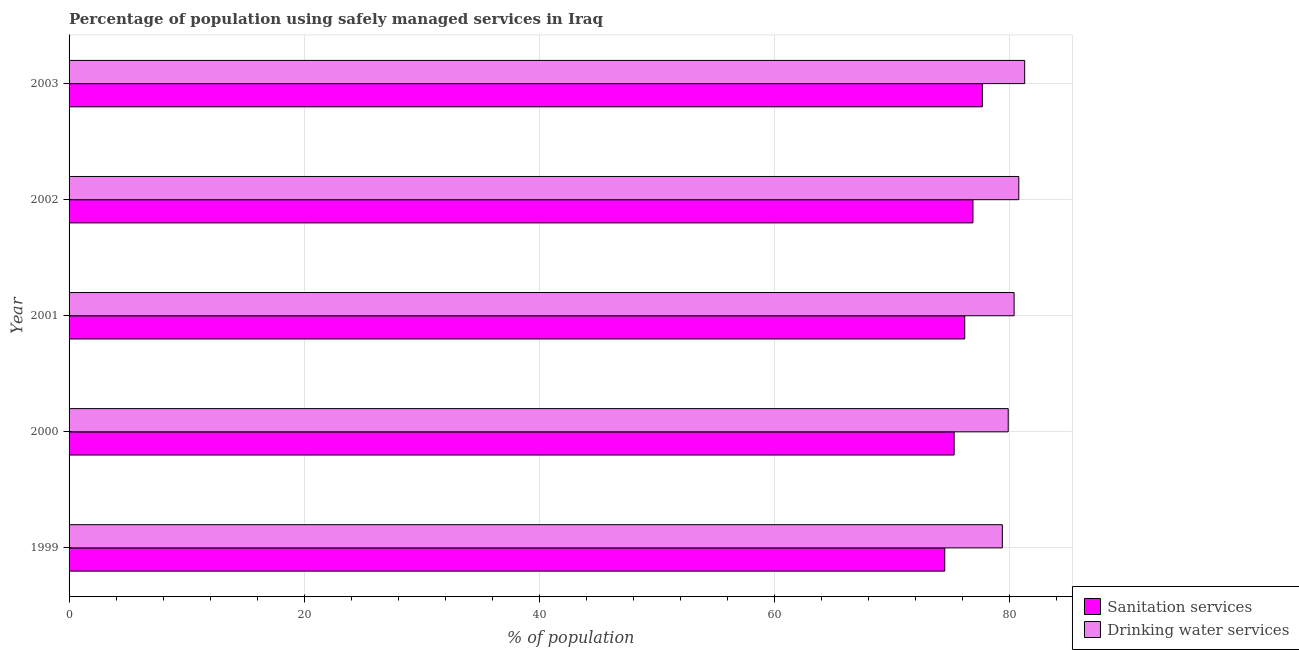How many different coloured bars are there?
Ensure brevity in your answer.  2. How many groups of bars are there?
Make the answer very short. 5. What is the label of the 4th group of bars from the top?
Provide a succinct answer. 2000. In how many cases, is the number of bars for a given year not equal to the number of legend labels?
Offer a terse response. 0. What is the percentage of population who used drinking water services in 2001?
Offer a very short reply. 80.4. Across all years, what is the maximum percentage of population who used sanitation services?
Ensure brevity in your answer.  77.7. Across all years, what is the minimum percentage of population who used drinking water services?
Offer a very short reply. 79.4. In which year was the percentage of population who used drinking water services maximum?
Offer a terse response. 2003. What is the total percentage of population who used drinking water services in the graph?
Offer a very short reply. 401.8. What is the difference between the percentage of population who used sanitation services in 2000 and that in 2001?
Ensure brevity in your answer.  -0.9. What is the difference between the percentage of population who used drinking water services in 2002 and the percentage of population who used sanitation services in 2003?
Your response must be concise. 3.1. What is the average percentage of population who used drinking water services per year?
Ensure brevity in your answer.  80.36. In the year 2002, what is the difference between the percentage of population who used drinking water services and percentage of population who used sanitation services?
Offer a very short reply. 3.9. What is the ratio of the percentage of population who used sanitation services in 1999 to that in 2001?
Your response must be concise. 0.98. Is the difference between the percentage of population who used sanitation services in 1999 and 2001 greater than the difference between the percentage of population who used drinking water services in 1999 and 2001?
Offer a very short reply. No. In how many years, is the percentage of population who used drinking water services greater than the average percentage of population who used drinking water services taken over all years?
Your answer should be very brief. 3. Is the sum of the percentage of population who used drinking water services in 2001 and 2002 greater than the maximum percentage of population who used sanitation services across all years?
Offer a terse response. Yes. What does the 2nd bar from the top in 2002 represents?
Give a very brief answer. Sanitation services. What does the 2nd bar from the bottom in 2001 represents?
Your answer should be compact. Drinking water services. Are all the bars in the graph horizontal?
Keep it short and to the point. Yes. How many years are there in the graph?
Make the answer very short. 5. Are the values on the major ticks of X-axis written in scientific E-notation?
Offer a terse response. No. Does the graph contain any zero values?
Your response must be concise. No. Does the graph contain grids?
Provide a short and direct response. Yes. Where does the legend appear in the graph?
Your answer should be very brief. Bottom right. How many legend labels are there?
Keep it short and to the point. 2. How are the legend labels stacked?
Your answer should be compact. Vertical. What is the title of the graph?
Offer a terse response. Percentage of population using safely managed services in Iraq. Does "Age 15+" appear as one of the legend labels in the graph?
Offer a very short reply. No. What is the label or title of the X-axis?
Your answer should be very brief. % of population. What is the % of population in Sanitation services in 1999?
Keep it short and to the point. 74.5. What is the % of population of Drinking water services in 1999?
Offer a terse response. 79.4. What is the % of population of Sanitation services in 2000?
Offer a very short reply. 75.3. What is the % of population of Drinking water services in 2000?
Your answer should be compact. 79.9. What is the % of population in Sanitation services in 2001?
Give a very brief answer. 76.2. What is the % of population in Drinking water services in 2001?
Provide a succinct answer. 80.4. What is the % of population of Sanitation services in 2002?
Provide a short and direct response. 76.9. What is the % of population in Drinking water services in 2002?
Your response must be concise. 80.8. What is the % of population of Sanitation services in 2003?
Provide a short and direct response. 77.7. What is the % of population of Drinking water services in 2003?
Your answer should be compact. 81.3. Across all years, what is the maximum % of population of Sanitation services?
Offer a terse response. 77.7. Across all years, what is the maximum % of population of Drinking water services?
Provide a succinct answer. 81.3. Across all years, what is the minimum % of population in Sanitation services?
Make the answer very short. 74.5. Across all years, what is the minimum % of population of Drinking water services?
Keep it short and to the point. 79.4. What is the total % of population of Sanitation services in the graph?
Give a very brief answer. 380.6. What is the total % of population of Drinking water services in the graph?
Keep it short and to the point. 401.8. What is the difference between the % of population in Drinking water services in 1999 and that in 2003?
Keep it short and to the point. -1.9. What is the difference between the % of population of Sanitation services in 2000 and that in 2001?
Offer a very short reply. -0.9. What is the difference between the % of population of Sanitation services in 2000 and that in 2002?
Ensure brevity in your answer.  -1.6. What is the difference between the % of population of Drinking water services in 2000 and that in 2002?
Offer a terse response. -0.9. What is the difference between the % of population in Drinking water services in 2000 and that in 2003?
Provide a succinct answer. -1.4. What is the difference between the % of population of Sanitation services in 2001 and that in 2002?
Provide a short and direct response. -0.7. What is the difference between the % of population of Drinking water services in 2001 and that in 2002?
Your answer should be compact. -0.4. What is the difference between the % of population of Sanitation services in 2001 and that in 2003?
Provide a short and direct response. -1.5. What is the difference between the % of population of Drinking water services in 2002 and that in 2003?
Offer a terse response. -0.5. What is the difference between the % of population in Sanitation services in 1999 and the % of population in Drinking water services in 2000?
Provide a succinct answer. -5.4. What is the difference between the % of population in Sanitation services in 1999 and the % of population in Drinking water services in 2003?
Offer a terse response. -6.8. What is the difference between the % of population of Sanitation services in 2000 and the % of population of Drinking water services in 2001?
Ensure brevity in your answer.  -5.1. What is the difference between the % of population in Sanitation services in 2001 and the % of population in Drinking water services in 2003?
Keep it short and to the point. -5.1. What is the average % of population in Sanitation services per year?
Ensure brevity in your answer.  76.12. What is the average % of population in Drinking water services per year?
Provide a succinct answer. 80.36. In the year 2000, what is the difference between the % of population in Sanitation services and % of population in Drinking water services?
Keep it short and to the point. -4.6. In the year 2001, what is the difference between the % of population in Sanitation services and % of population in Drinking water services?
Ensure brevity in your answer.  -4.2. What is the ratio of the % of population of Drinking water services in 1999 to that in 2000?
Your answer should be very brief. 0.99. What is the ratio of the % of population in Sanitation services in 1999 to that in 2001?
Your answer should be compact. 0.98. What is the ratio of the % of population in Drinking water services in 1999 to that in 2001?
Provide a succinct answer. 0.99. What is the ratio of the % of population of Sanitation services in 1999 to that in 2002?
Provide a short and direct response. 0.97. What is the ratio of the % of population in Drinking water services in 1999 to that in 2002?
Make the answer very short. 0.98. What is the ratio of the % of population of Sanitation services in 1999 to that in 2003?
Provide a succinct answer. 0.96. What is the ratio of the % of population of Drinking water services in 1999 to that in 2003?
Your response must be concise. 0.98. What is the ratio of the % of population in Sanitation services in 2000 to that in 2002?
Ensure brevity in your answer.  0.98. What is the ratio of the % of population in Drinking water services in 2000 to that in 2002?
Ensure brevity in your answer.  0.99. What is the ratio of the % of population of Sanitation services in 2000 to that in 2003?
Your answer should be compact. 0.97. What is the ratio of the % of population in Drinking water services in 2000 to that in 2003?
Provide a short and direct response. 0.98. What is the ratio of the % of population in Sanitation services in 2001 to that in 2002?
Your answer should be very brief. 0.99. What is the ratio of the % of population of Drinking water services in 2001 to that in 2002?
Provide a succinct answer. 0.99. What is the ratio of the % of population of Sanitation services in 2001 to that in 2003?
Give a very brief answer. 0.98. What is the ratio of the % of population in Drinking water services in 2001 to that in 2003?
Offer a very short reply. 0.99. What is the difference between the highest and the second highest % of population of Sanitation services?
Give a very brief answer. 0.8. What is the difference between the highest and the second highest % of population in Drinking water services?
Ensure brevity in your answer.  0.5. What is the difference between the highest and the lowest % of population in Sanitation services?
Ensure brevity in your answer.  3.2. What is the difference between the highest and the lowest % of population of Drinking water services?
Make the answer very short. 1.9. 